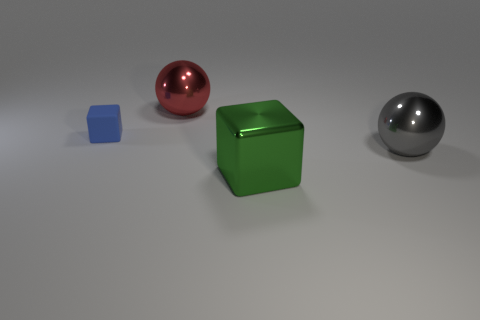Add 2 small red rubber cylinders. How many objects exist? 6 Add 4 big blocks. How many big blocks exist? 5 Subtract 0 brown cylinders. How many objects are left? 4 Subtract all matte cubes. Subtract all large gray shiny objects. How many objects are left? 2 Add 3 big gray objects. How many big gray objects are left? 4 